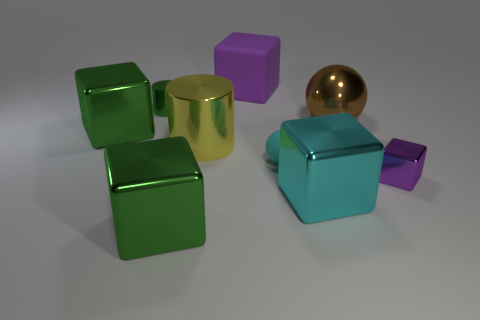Subtract all purple rubber blocks. How many blocks are left? 4 Subtract all gray cylinders. How many purple blocks are left? 2 Subtract all cyan balls. How many balls are left? 1 Subtract all blocks. How many objects are left? 4 Subtract 1 brown balls. How many objects are left? 8 Subtract all red cubes. Subtract all yellow balls. How many cubes are left? 5 Subtract all blue cylinders. Subtract all big yellow metallic objects. How many objects are left? 8 Add 2 large purple objects. How many large purple objects are left? 3 Add 8 purple blocks. How many purple blocks exist? 10 